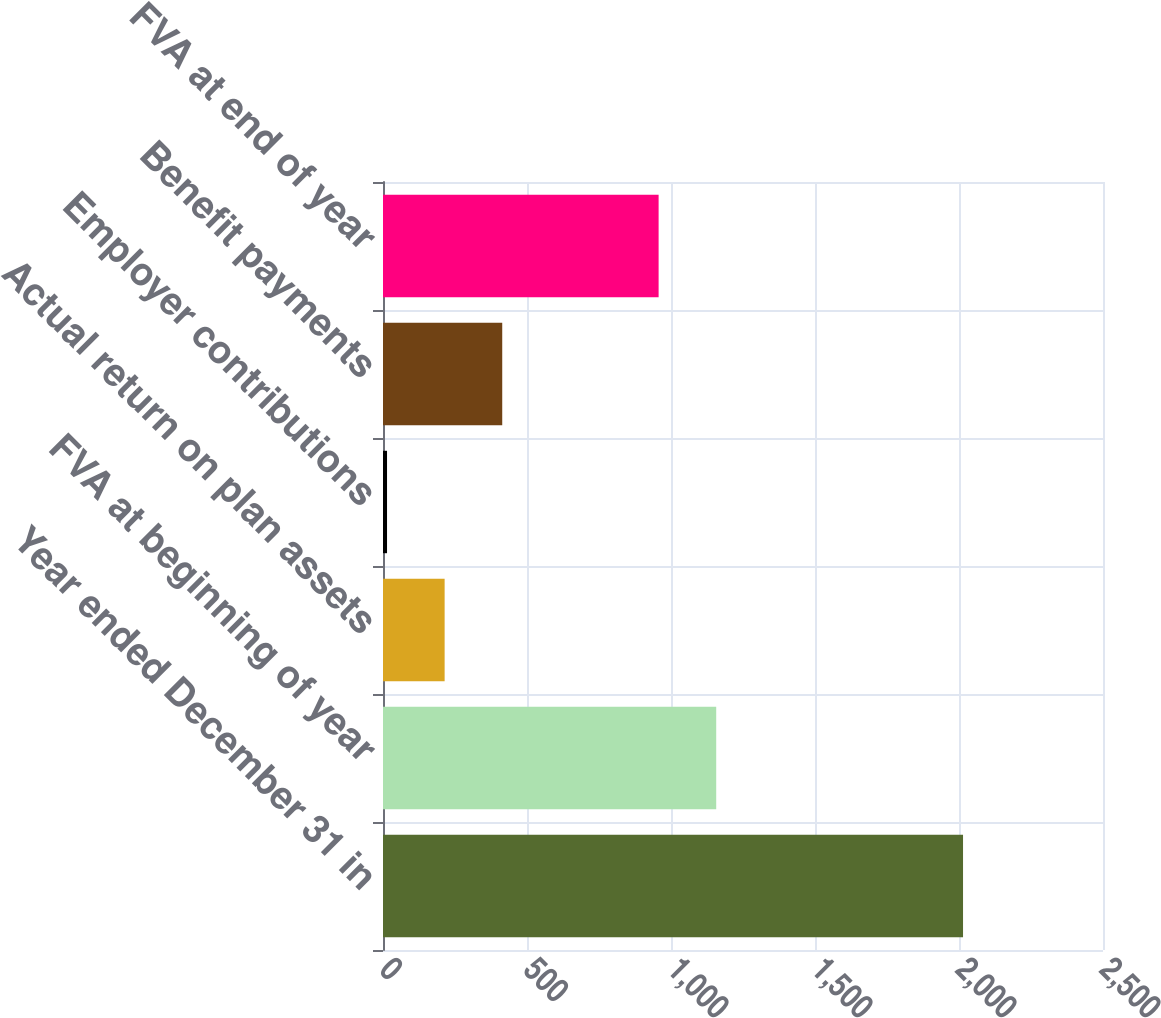Convert chart to OTSL. <chart><loc_0><loc_0><loc_500><loc_500><bar_chart><fcel>Year ended December 31 in<fcel>FVA at beginning of year<fcel>Actual return on plan assets<fcel>Employer contributions<fcel>Benefit payments<fcel>FVA at end of year<nl><fcel>2014<fcel>1157<fcel>214<fcel>14<fcel>414<fcel>957<nl></chart> 